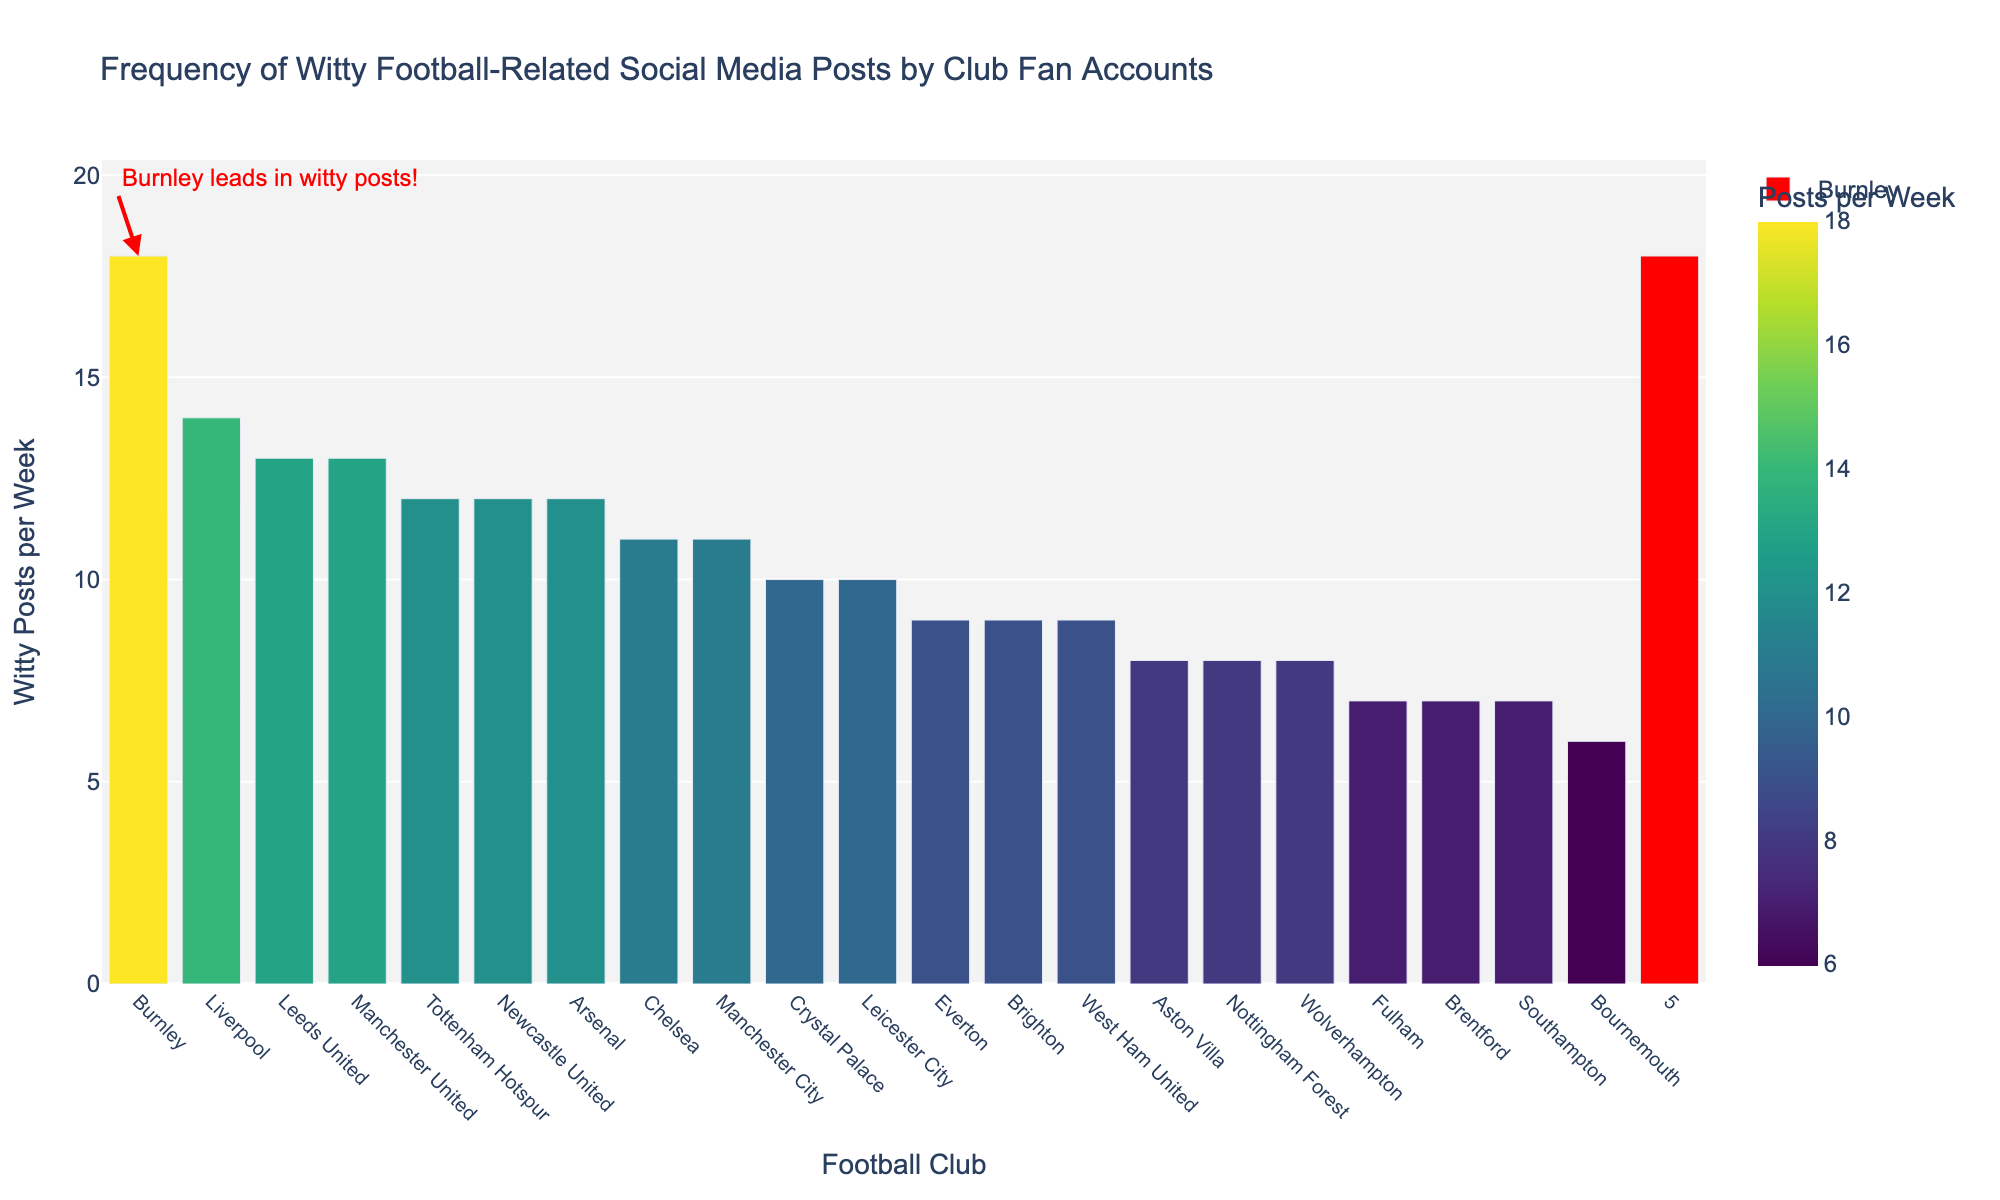Which club has the most witty posts per week? According to the bar chart, Burnley has the highest number of witty posts among the football clubs.
Answer: Burnley How many more witty posts does Burnley have per week compared to Liverpool? Burnley has 18 witty posts per week, while Liverpool has 14. The difference is 18 - 14 = 4 posts.
Answer: 4 Which clubs have an equal number of witty posts per week? By observing the heights of the bars, Arsenal, Newcastle United, and Tottenham Hotspur each have 12 witty posts per week.
Answer: Arsenal, Newcastle United, Tottenham Hotspur What is the average number of witty posts per week for Arsenal and Chelsea? Arsenal has 12 witty posts per week, and Chelsea has 11. The average is (12 + 11) / 2 = 11.5 posts per week.
Answer: 11.5 How does Burnley's number of witty posts compare visually to the rest? Burnley's bar is highlighted in red and noticeably higher than the rest, indicating it leads in witty posts per week.
Answer: Highest Which club has the least number of witty posts per week? Observing the heights of the bars, Bournemouth has the shortest bar, indicating it has the least number of witty posts at 6 per week.
Answer: Bournemouth What is the sum of witty posts per week for the clubs with 8 posts? Aston Villa, Nottingham Forest, and Wolverhampton each have 8 witty posts per week. The total is 8 + 8 + 8 = 24.
Answer: 24 How many clubs have more than 10 witty posts per week? By counting the bars with values above 10, we find there are six clubs: Arsenal, Chelsea, Leeds United, Liverpool, Manchester United, and Tottenham Hotspur.
Answer: 6 What color is used to highlight the club with the most witty posts? The bar for Burnley, which has the most witty posts, is highlighted in red.
Answer: Red 